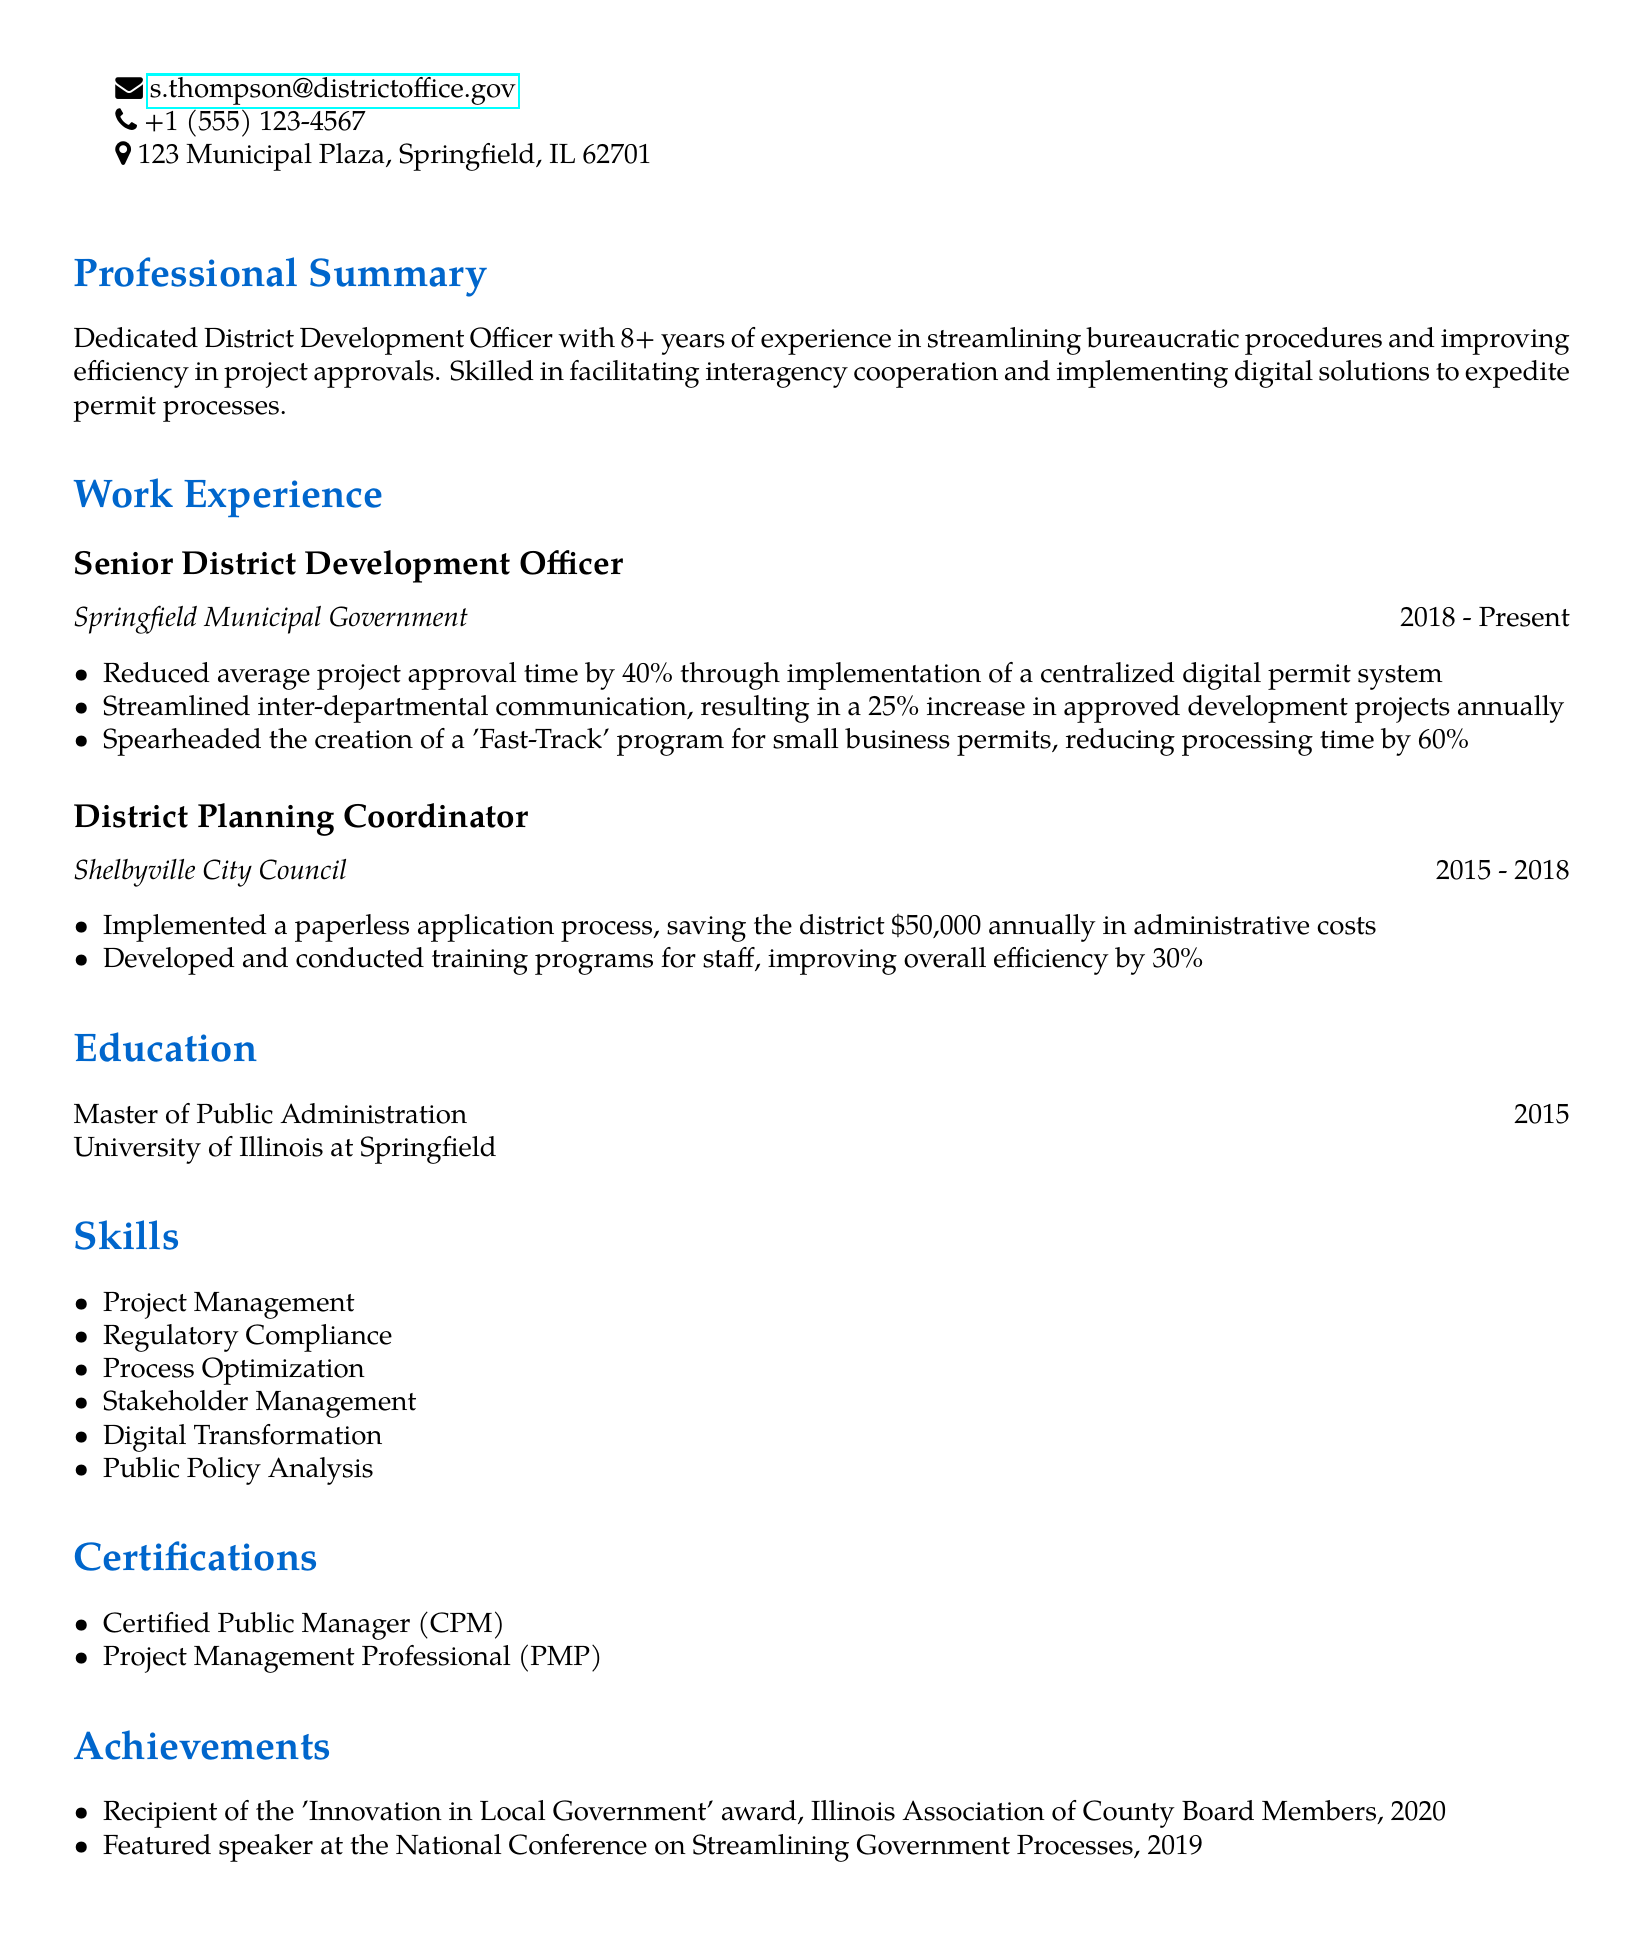What is the name of the District Development Officer? The name provided in the document is Sarah J. Thompson.
Answer: Sarah J. Thompson How many years of experience does Sarah J. Thompson have? The document states she has 8+ years of experience.
Answer: 8+ years What is the position currently held by Sarah J. Thompson? The document mentions her position as Senior District Development Officer.
Answer: Senior District Development Officer What percentage did the project approval time reduce due to the digital permit system? The document indicates a reduction of 40% in project approval time.
Answer: 40% What was the annual savings achieved by implementing a paperless application process? The document notes an annual saving of $50,000.
Answer: $50,000 Which award did Sarah J. Thompson receive in 2020? The document mentions she received the 'Innovation in Local Government' award.
Answer: 'Innovation in Local Government' What program did Sarah J. Thompson create to expedite small business permits? The document describes a 'Fast-Track' program for small business permits.
Answer: 'Fast-Track' program What skill does Sarah J. Thompson have related to stakeholder relationships? The document lists Stakeholder Management as one of her skills.
Answer: Stakeholder Management At which university did Sarah J. Thompson obtain her Master's degree? The document states she obtained her degree from the University of Illinois at Springfield.
Answer: University of Illinois at Springfield 